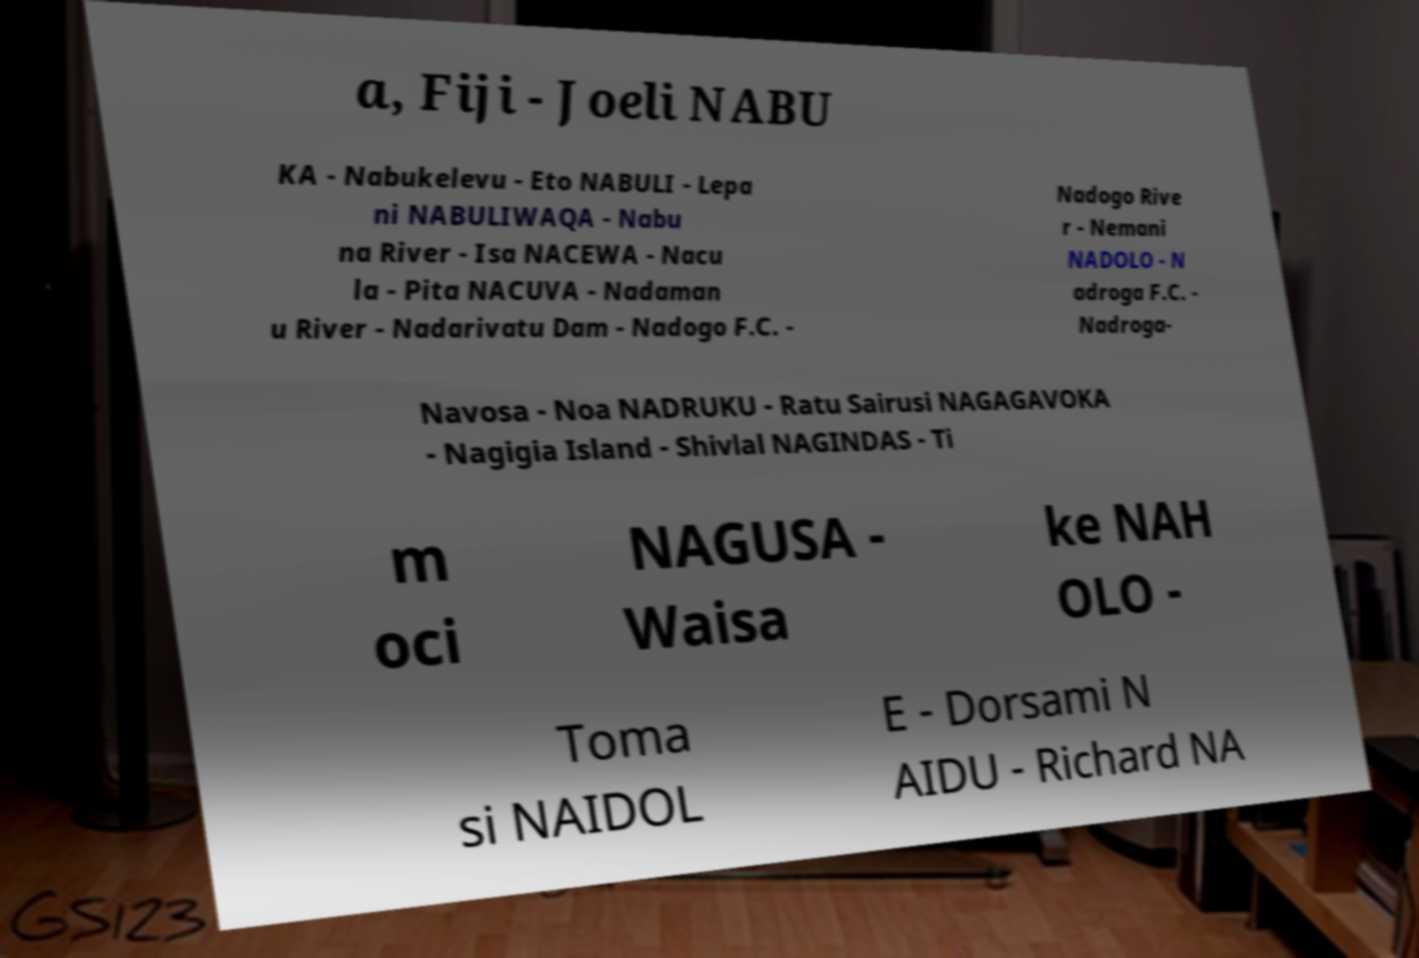Can you read and provide the text displayed in the image?This photo seems to have some interesting text. Can you extract and type it out for me? a, Fiji - Joeli NABU KA - Nabukelevu - Eto NABULI - Lepa ni NABULIWAQA - Nabu na River - Isa NACEWA - Nacu la - Pita NACUVA - Nadaman u River - Nadarivatu Dam - Nadogo F.C. - Nadogo Rive r - Nemani NADOLO - N adroga F.C. - Nadroga- Navosa - Noa NADRUKU - Ratu Sairusi NAGAGAVOKA - Nagigia Island - Shivlal NAGINDAS - Ti m oci NAGUSA - Waisa ke NAH OLO - Toma si NAIDOL E - Dorsami N AIDU - Richard NA 